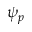Convert formula to latex. <formula><loc_0><loc_0><loc_500><loc_500>\psi _ { p }</formula> 